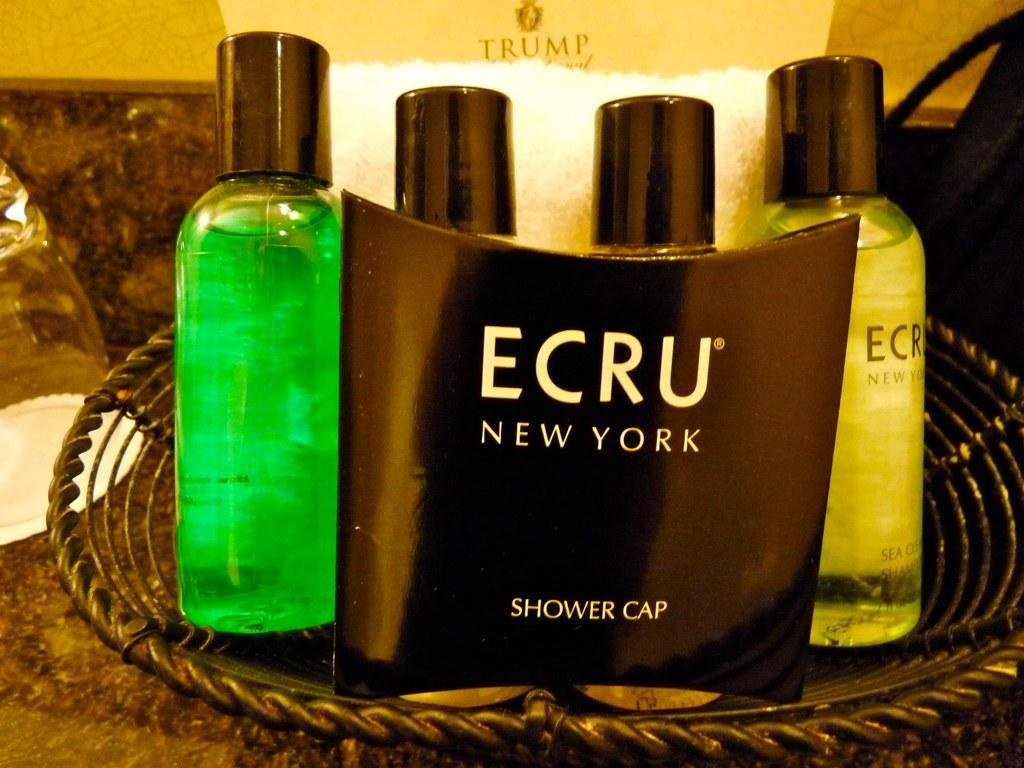Provide a one-sentence caption for the provided image. A basket of toiletries is from the Trump hotel. 